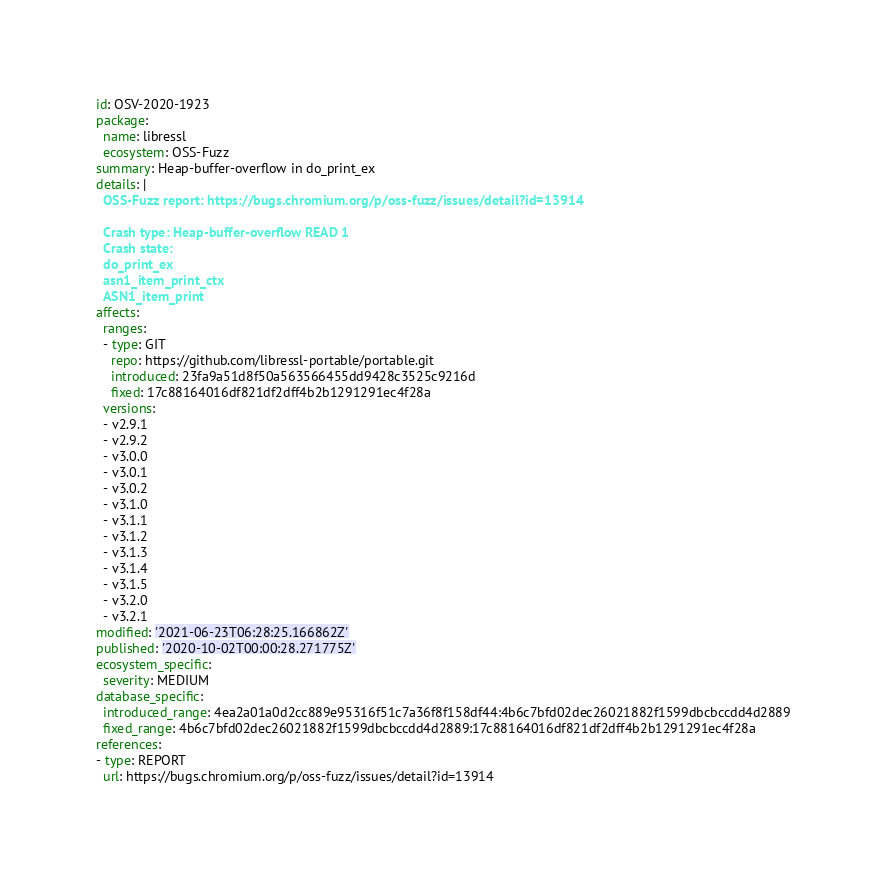<code> <loc_0><loc_0><loc_500><loc_500><_YAML_>id: OSV-2020-1923
package:
  name: libressl
  ecosystem: OSS-Fuzz
summary: Heap-buffer-overflow in do_print_ex
details: |
  OSS-Fuzz report: https://bugs.chromium.org/p/oss-fuzz/issues/detail?id=13914

  Crash type: Heap-buffer-overflow READ 1
  Crash state:
  do_print_ex
  asn1_item_print_ctx
  ASN1_item_print
affects:
  ranges:
  - type: GIT
    repo: https://github.com/libressl-portable/portable.git
    introduced: 23fa9a51d8f50a563566455dd9428c3525c9216d
    fixed: 17c88164016df821df2dff4b2b1291291ec4f28a
  versions:
  - v2.9.1
  - v2.9.2
  - v3.0.0
  - v3.0.1
  - v3.0.2
  - v3.1.0
  - v3.1.1
  - v3.1.2
  - v3.1.3
  - v3.1.4
  - v3.1.5
  - v3.2.0
  - v3.2.1
modified: '2021-06-23T06:28:25.166862Z'
published: '2020-10-02T00:00:28.271775Z'
ecosystem_specific:
  severity: MEDIUM
database_specific:
  introduced_range: 4ea2a01a0d2cc889e95316f51c7a36f8f158df44:4b6c7bfd02dec26021882f1599dbcbccdd4d2889
  fixed_range: 4b6c7bfd02dec26021882f1599dbcbccdd4d2889:17c88164016df821df2dff4b2b1291291ec4f28a
references:
- type: REPORT
  url: https://bugs.chromium.org/p/oss-fuzz/issues/detail?id=13914
</code> 